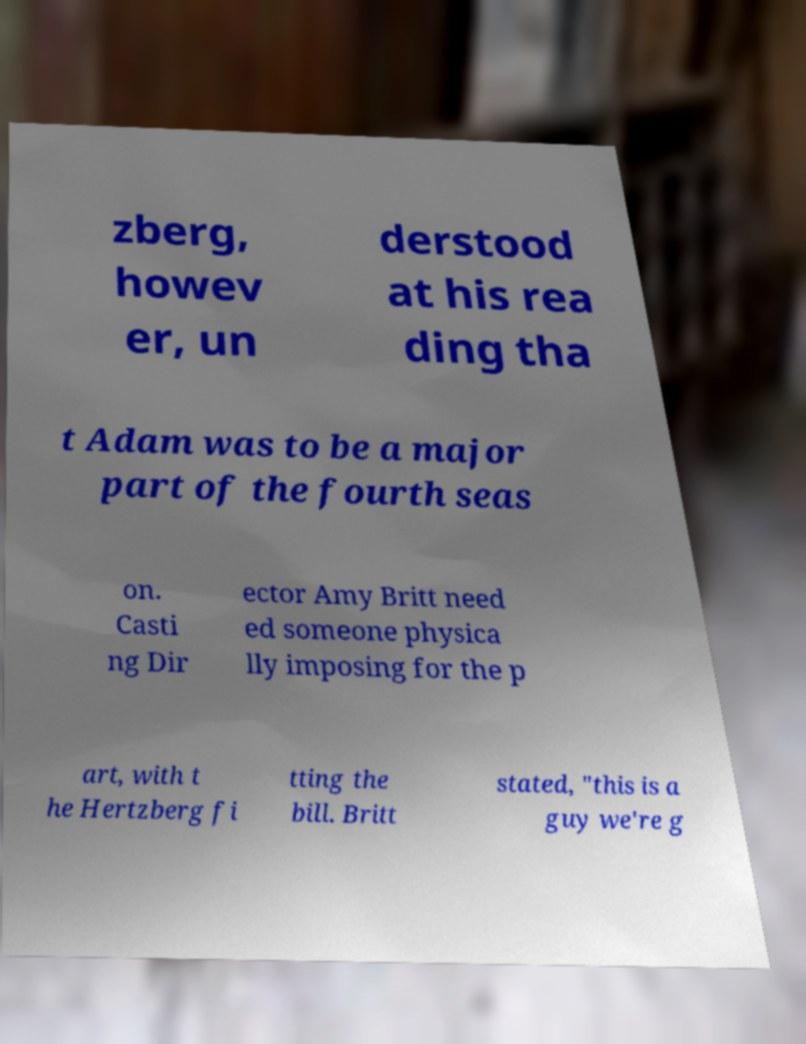Can you accurately transcribe the text from the provided image for me? zberg, howev er, un derstood at his rea ding tha t Adam was to be a major part of the fourth seas on. Casti ng Dir ector Amy Britt need ed someone physica lly imposing for the p art, with t he Hertzberg fi tting the bill. Britt stated, "this is a guy we're g 